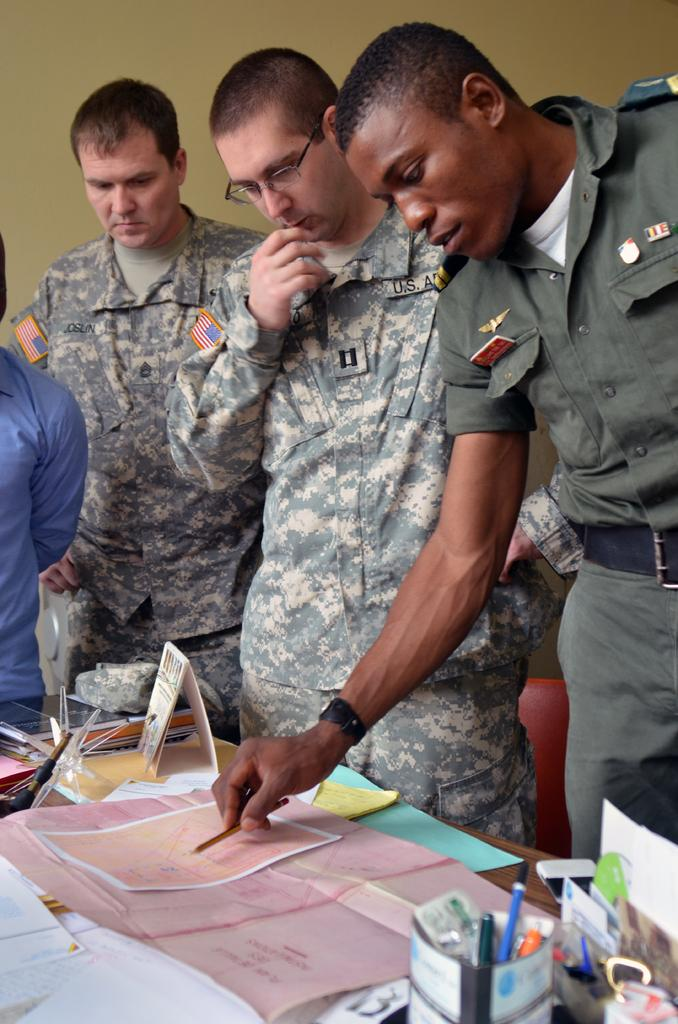What is the main subject of the image? The main subject of the image is men in the center. What type of men are depicted in the image? The men appear to be soldiers. What type of street can be seen in the image? There is no street visible in the image; it features men who appear to be soldiers. Is there a ring present in the image? There is no ring present in the image. 